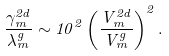Convert formula to latex. <formula><loc_0><loc_0><loc_500><loc_500>\frac { \gamma _ { m } ^ { 2 d } } { \lambda _ { m } ^ { g } } \sim 1 0 ^ { 2 } \left ( \frac { V _ { m } ^ { 2 d } } { V _ { m } ^ { g } } \right ) ^ { 2 } .</formula> 